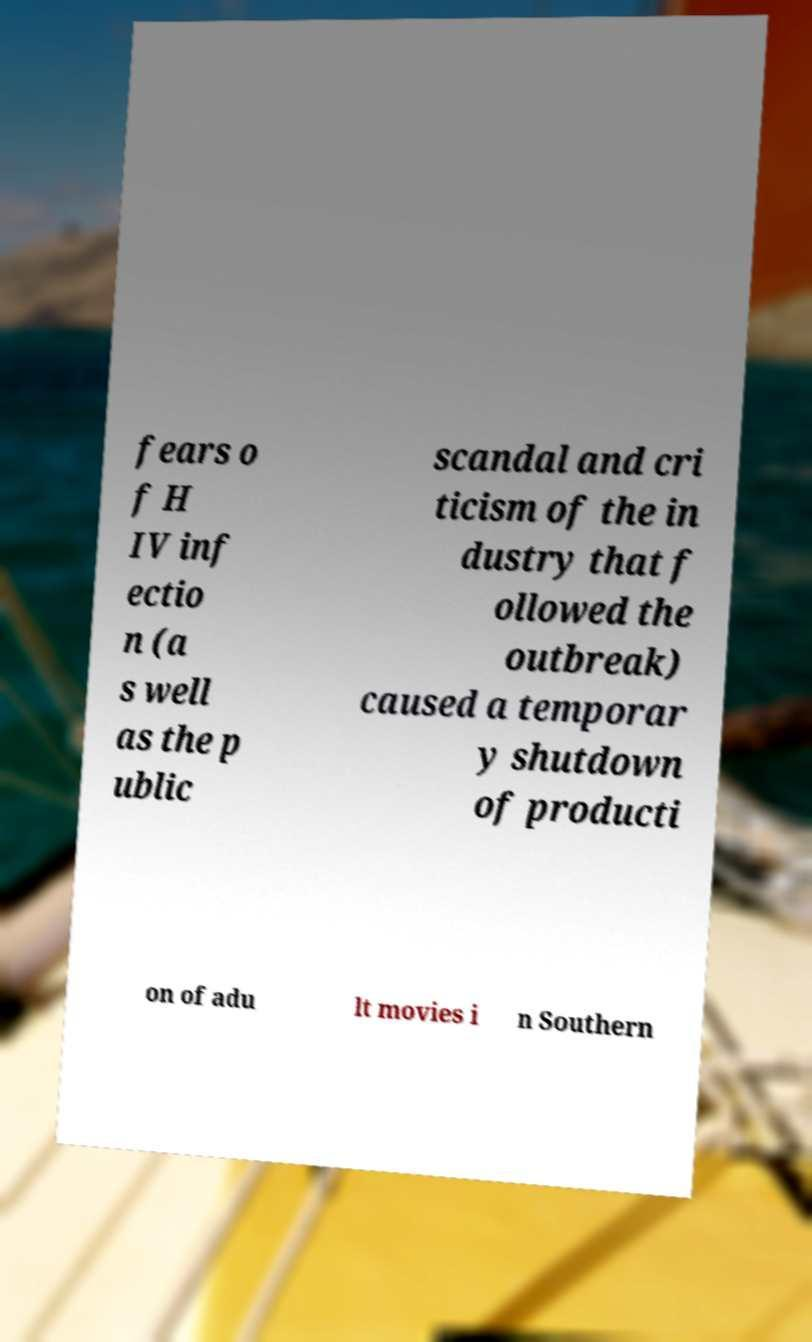Can you read and provide the text displayed in the image?This photo seems to have some interesting text. Can you extract and type it out for me? fears o f H IV inf ectio n (a s well as the p ublic scandal and cri ticism of the in dustry that f ollowed the outbreak) caused a temporar y shutdown of producti on of adu lt movies i n Southern 